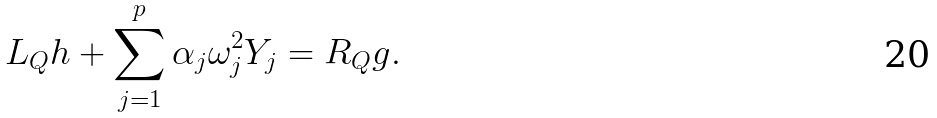<formula> <loc_0><loc_0><loc_500><loc_500>L _ { Q } h + \sum _ { j = 1 } ^ { p } \alpha _ { j } \omega _ { j } ^ { 2 } Y _ { j } = R _ { Q } g .</formula> 